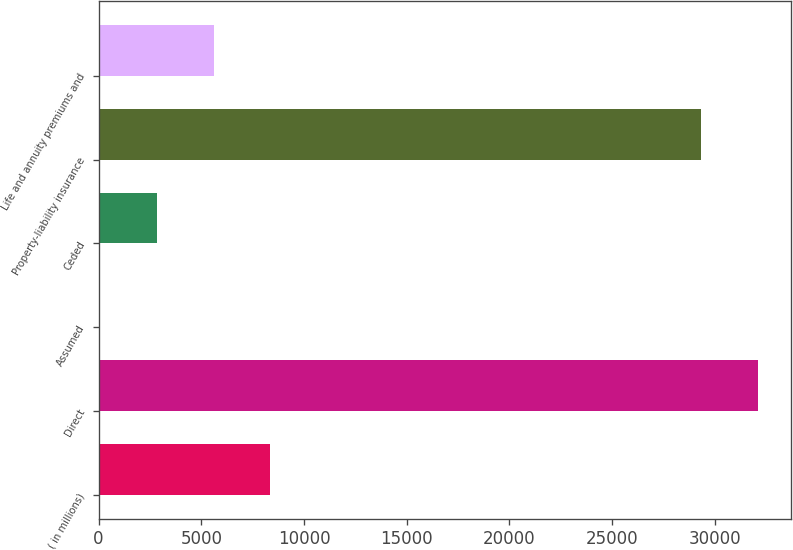Convert chart to OTSL. <chart><loc_0><loc_0><loc_500><loc_500><bar_chart><fcel>( in millions)<fcel>Direct<fcel>Assumed<fcel>Ceded<fcel>Property-liability insurance<fcel>Life and annuity premiums and<nl><fcel>8359.6<fcel>32100.4<fcel>85<fcel>2843.2<fcel>29342.2<fcel>5601.4<nl></chart> 